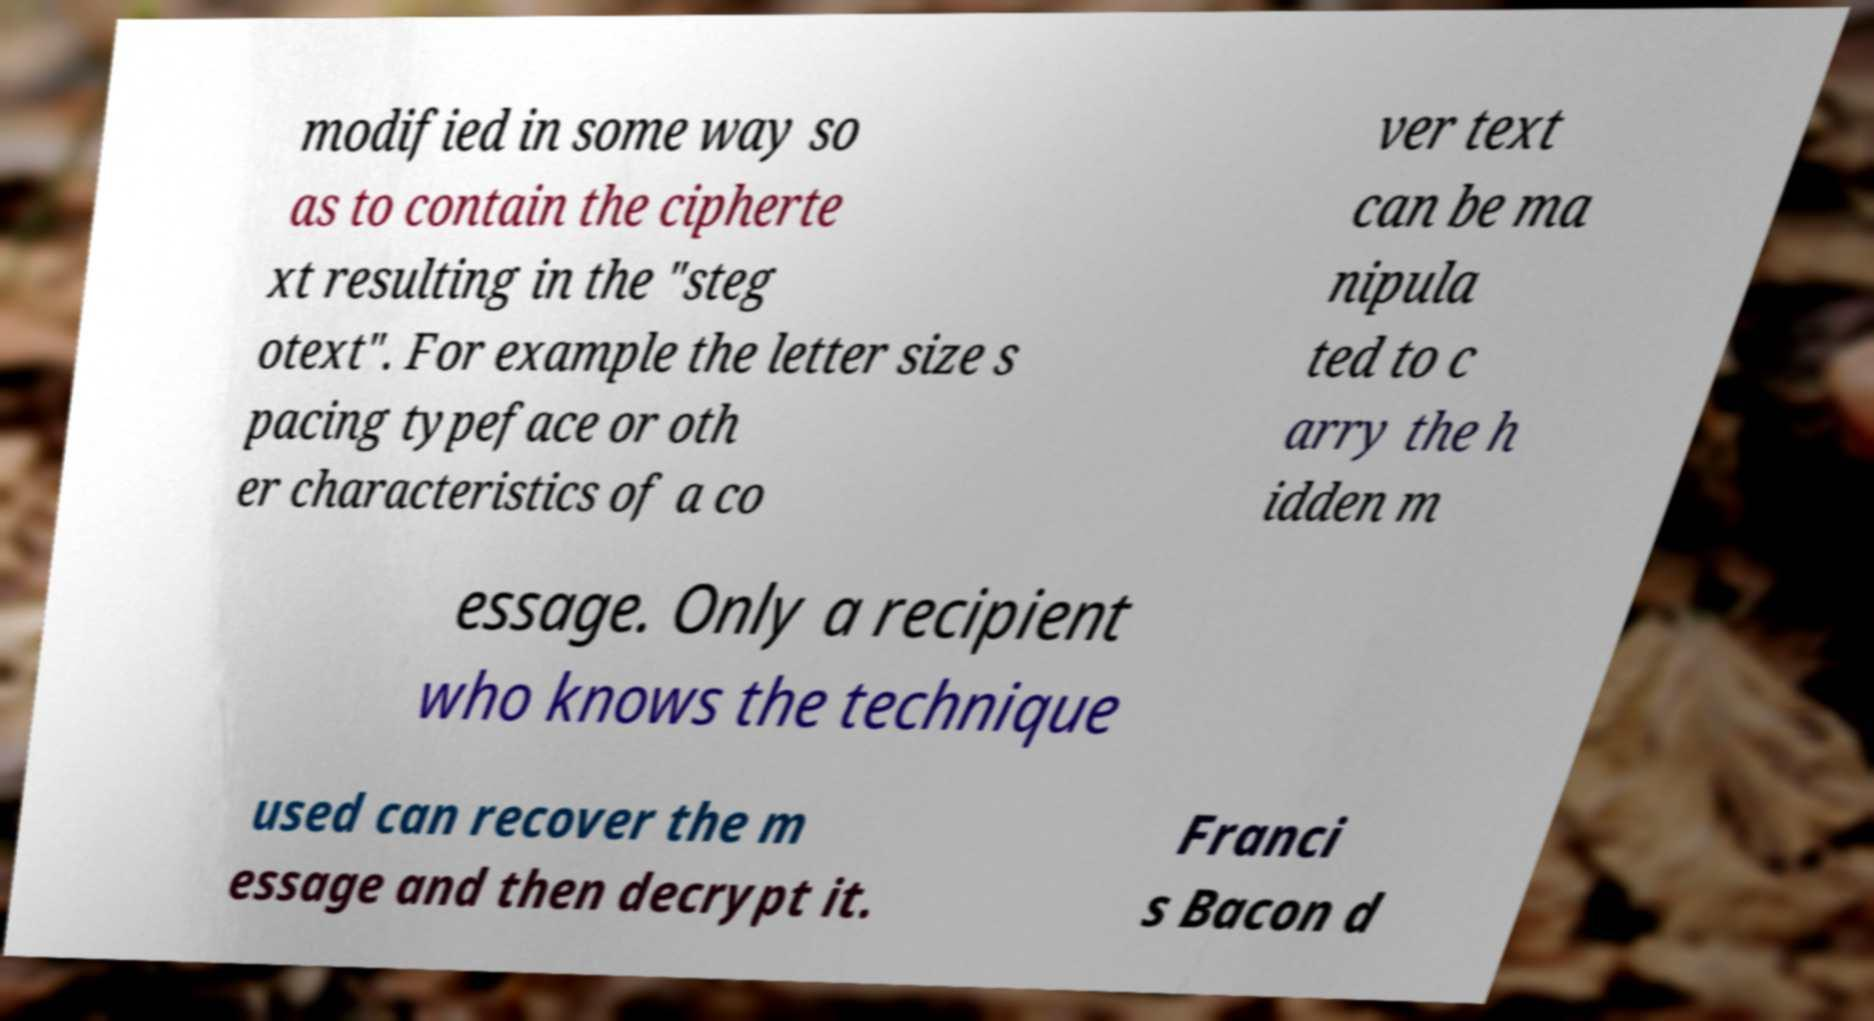Can you accurately transcribe the text from the provided image for me? modified in some way so as to contain the cipherte xt resulting in the "steg otext". For example the letter size s pacing typeface or oth er characteristics of a co ver text can be ma nipula ted to c arry the h idden m essage. Only a recipient who knows the technique used can recover the m essage and then decrypt it. Franci s Bacon d 